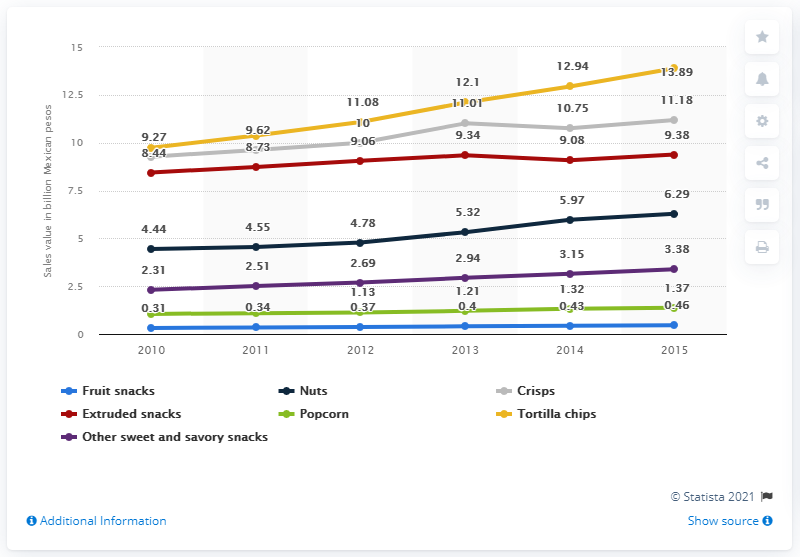Draw attention to some important aspects in this diagram. In 2015, the production of tortilla chips in Mexico generated 13.89 Mexican pesos. 